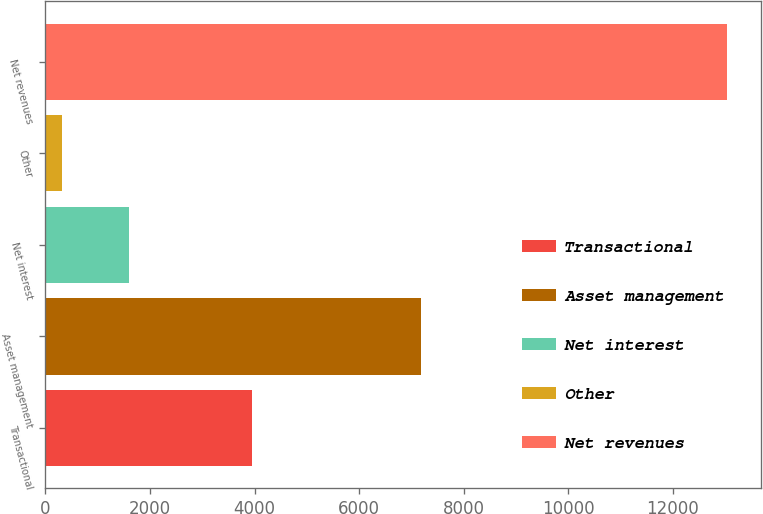<chart> <loc_0><loc_0><loc_500><loc_500><bar_chart><fcel>Transactional<fcel>Asset management<fcel>Net interest<fcel>Other<fcel>Net revenues<nl><fcel>3958<fcel>7190<fcel>1590.5<fcel>319<fcel>13034<nl></chart> 